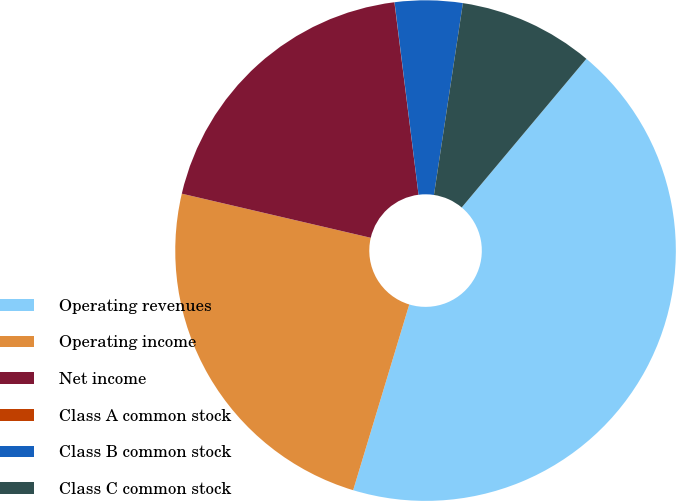Convert chart to OTSL. <chart><loc_0><loc_0><loc_500><loc_500><pie_chart><fcel>Operating revenues<fcel>Operating income<fcel>Net income<fcel>Class A common stock<fcel>Class B common stock<fcel>Class C common stock<nl><fcel>43.56%<fcel>23.98%<fcel>19.36%<fcel>0.01%<fcel>4.36%<fcel>8.72%<nl></chart> 